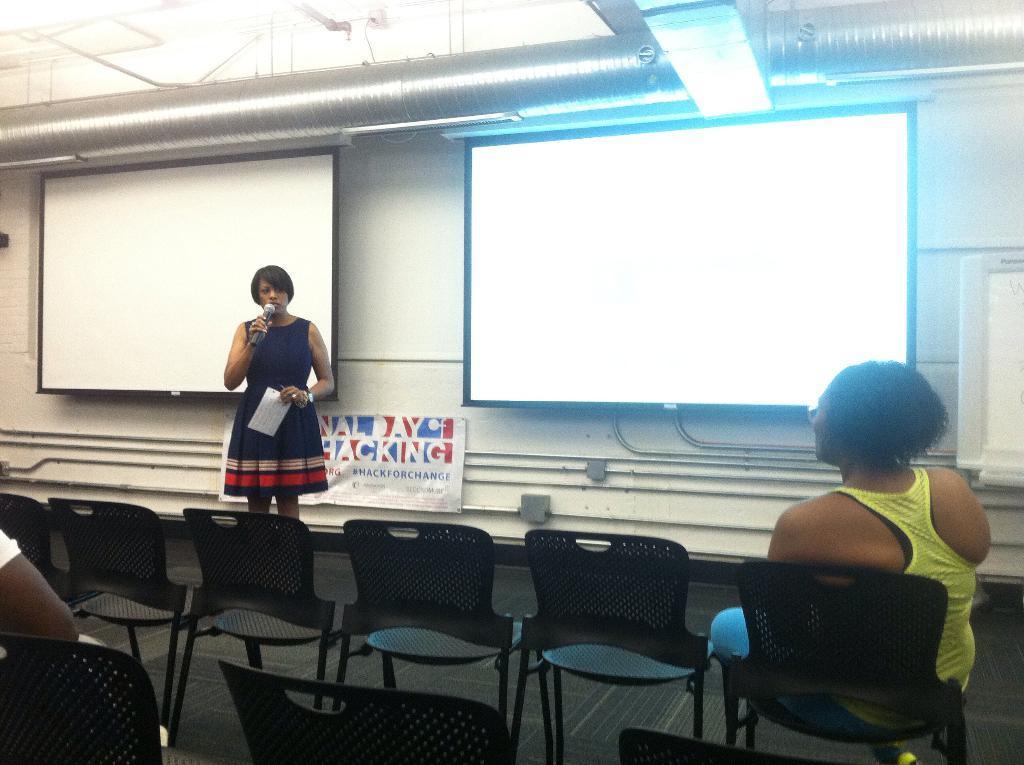Describe this image in one or two sentences. In this picture we can see a woman standing on the floor. These are the chairs. And there is a person who is sitting on the chair. On the background there are screens. This is the wall and this is the light. 